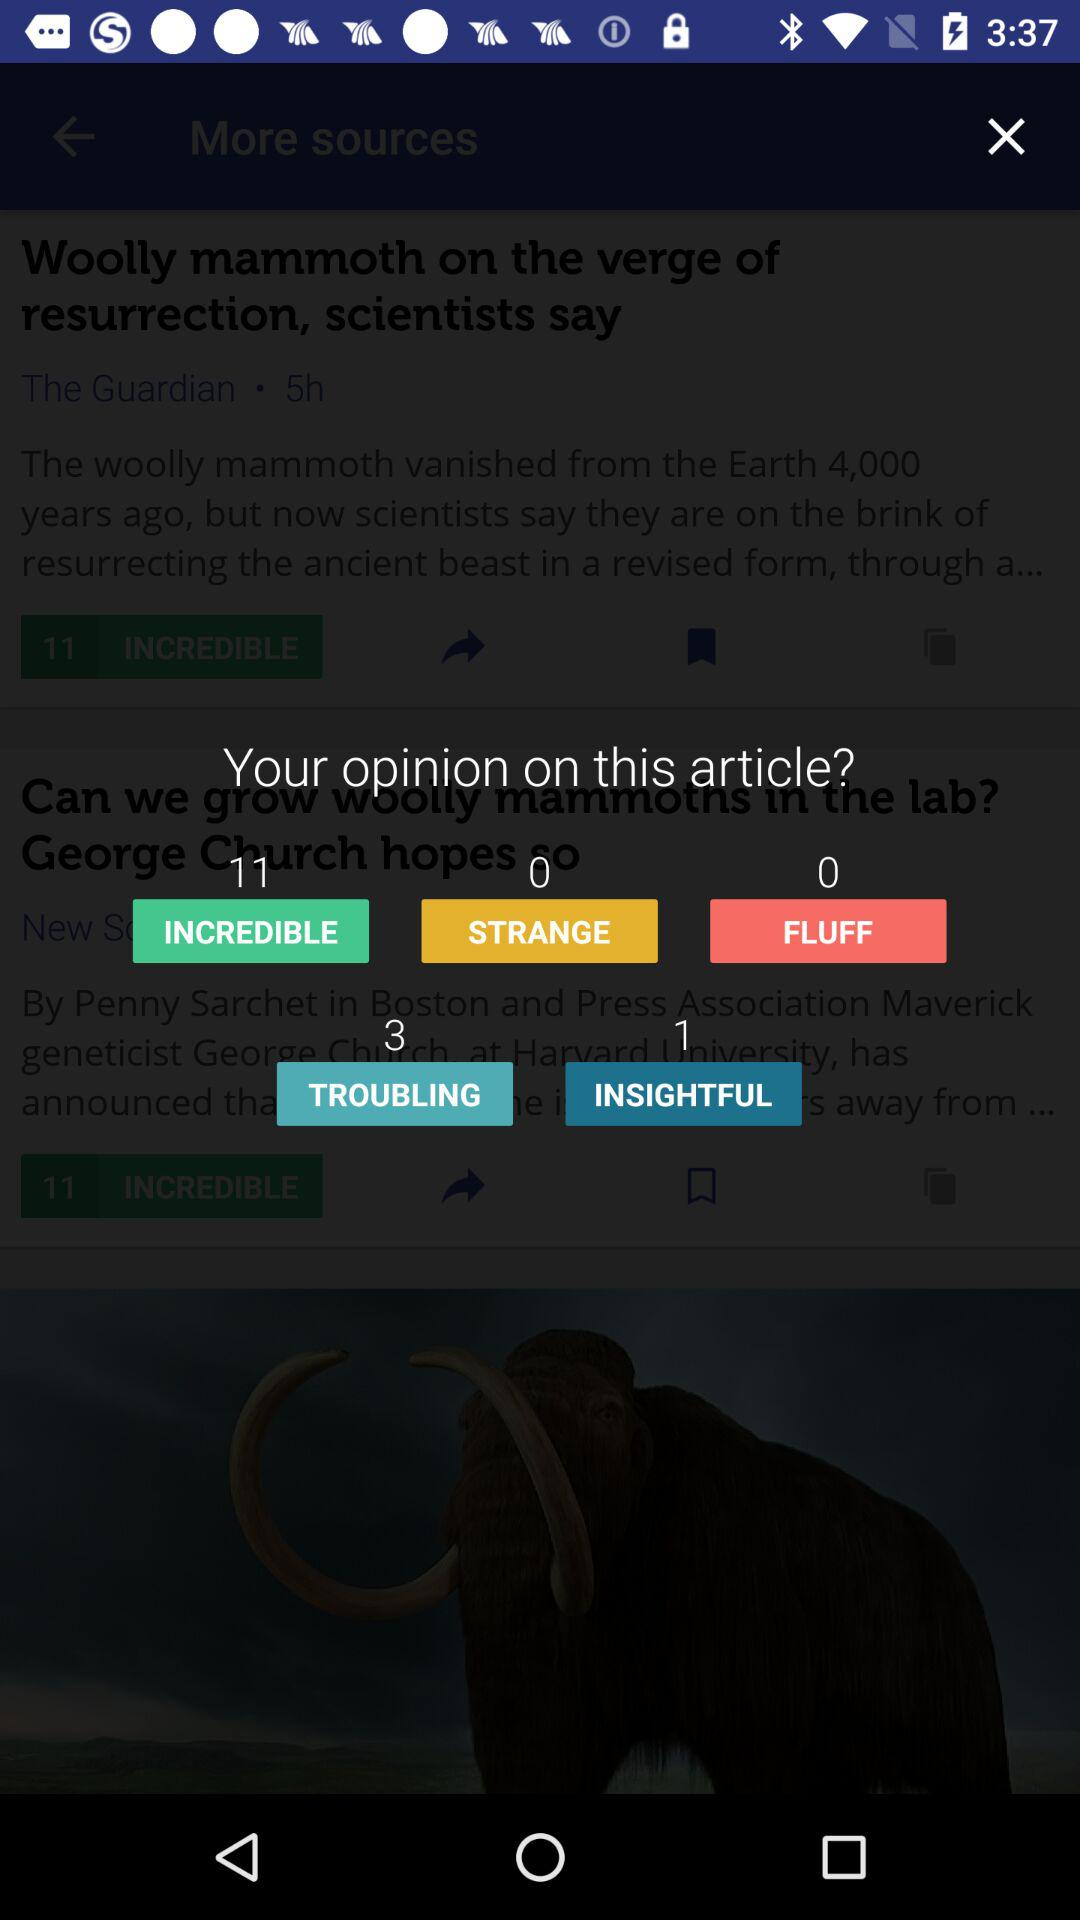What opinion is having 3 votes? The opinion is "TROUBLING". 